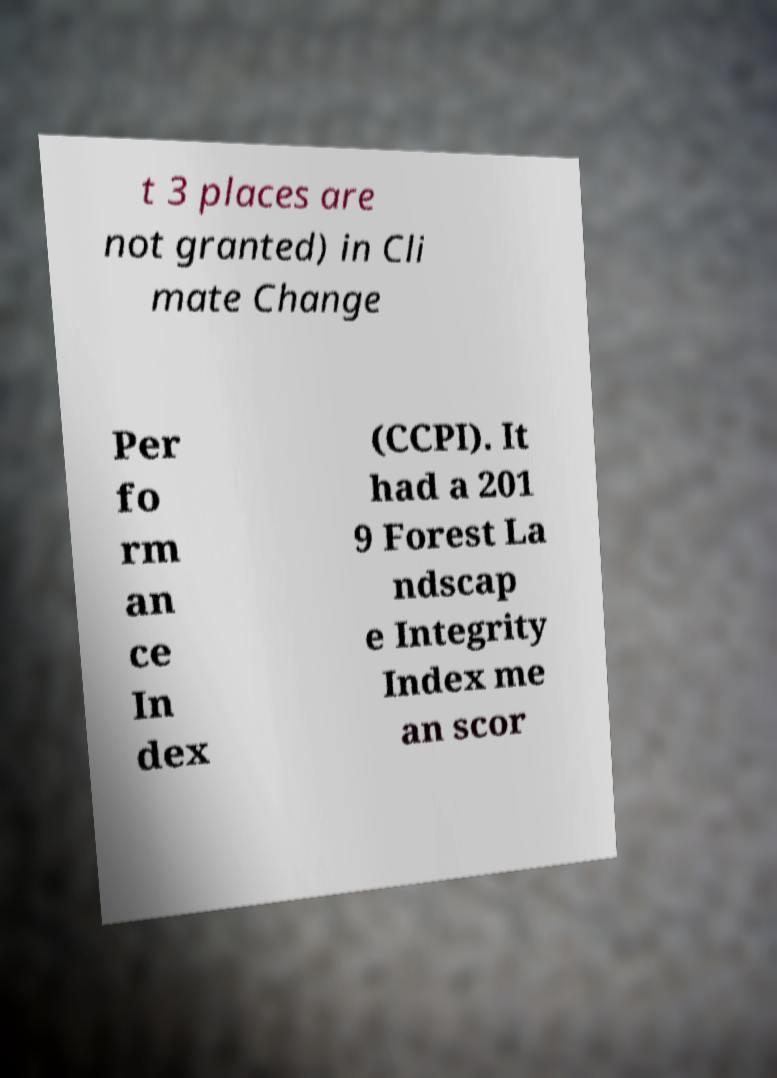What messages or text are displayed in this image? I need them in a readable, typed format. t 3 places are not granted) in Cli mate Change Per fo rm an ce In dex (CCPI). It had a 201 9 Forest La ndscap e Integrity Index me an scor 